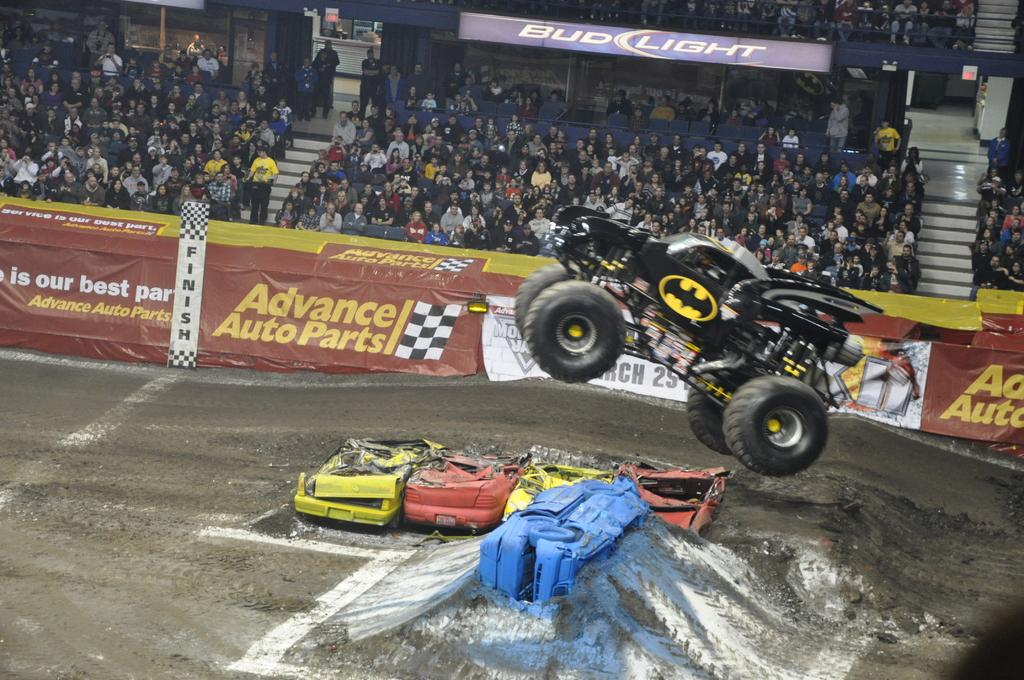What can be seen in the image that has wheels and is used for transportation? There are vehicles in the image that have wheels and are used for transportation. What is written on the banners in the back of the image? There are banners with text in the back of the image. How are people positioned in the image? There are many people sitting and standing in the image. What architectural feature is present in the image? There are steps in the image. Can you describe the hen wearing a dress in the image? There is no hen or dress present in the image. What type of jellyfish can be seen swimming in the background of the image? There are no jellyfish present in the image; it features vehicles, banners, and people. 